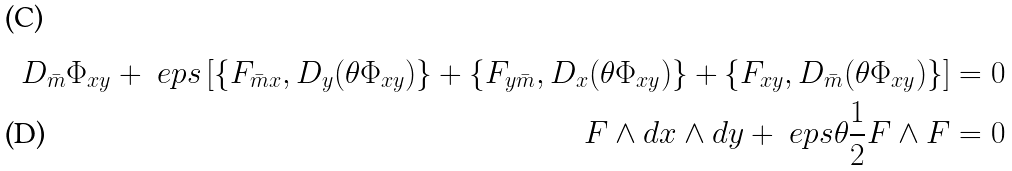Convert formula to latex. <formula><loc_0><loc_0><loc_500><loc_500>D _ { \bar { m } } \Phi _ { x y } + \ e p s \left [ \{ F _ { \bar { m } x } , D _ { y } ( \theta \Phi _ { x y } ) \} + \{ F _ { y \bar { m } } , D _ { x } ( \theta \Phi _ { x y } ) \} + \{ F _ { x y } , D _ { \bar { m } } ( \theta \Phi _ { x y } ) \} \right ] & = 0 \\ F \wedge d x \wedge d y + \ e p s \theta \frac { 1 } { 2 } F \wedge F & = 0</formula> 